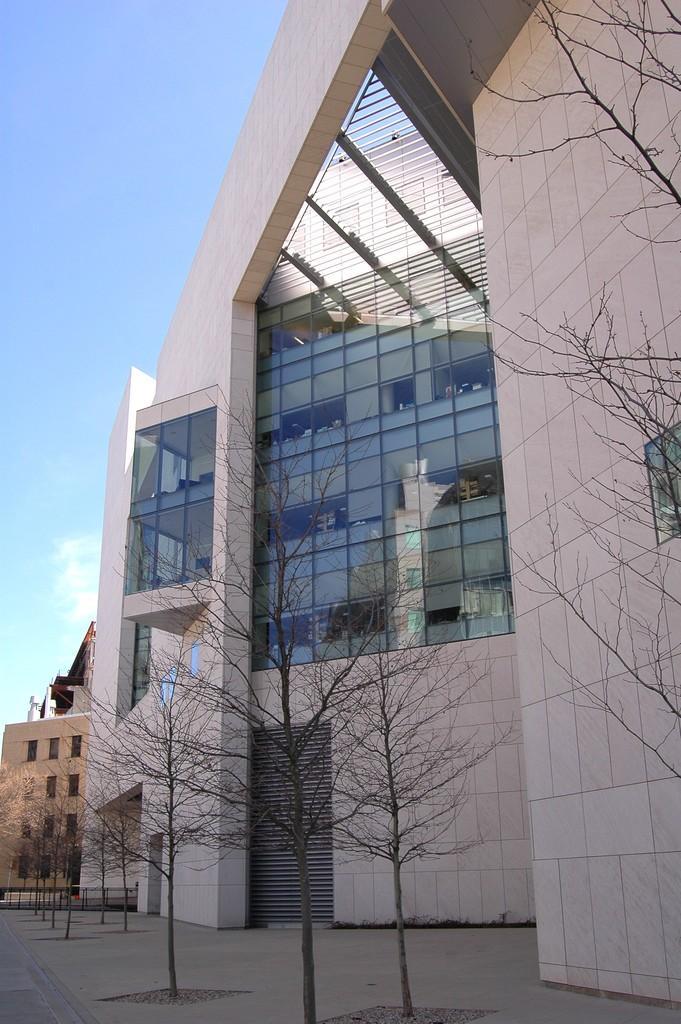In one or two sentences, can you explain what this image depicts? In this image we can see the buildings, trees, path and also the road. We can also see the sky with some clouds. 